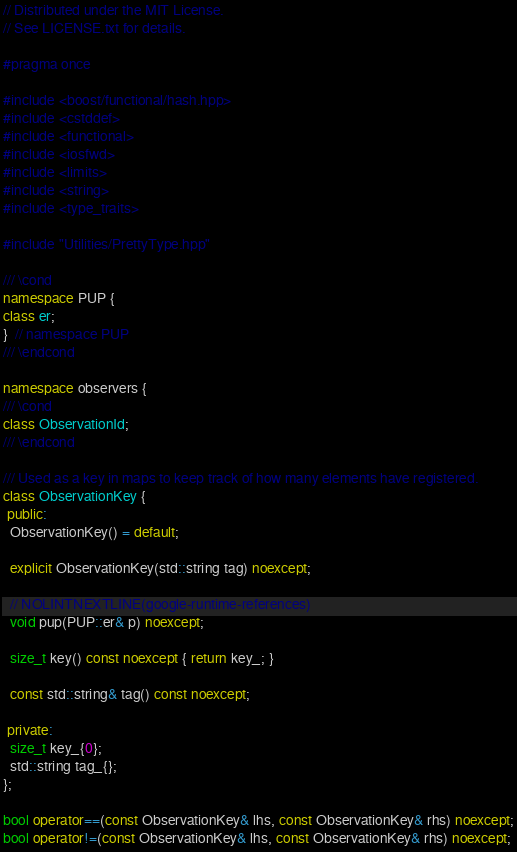Convert code to text. <code><loc_0><loc_0><loc_500><loc_500><_C++_>// Distributed under the MIT License.
// See LICENSE.txt for details.

#pragma once

#include <boost/functional/hash.hpp>
#include <cstddef>
#include <functional>
#include <iosfwd>
#include <limits>
#include <string>
#include <type_traits>

#include "Utilities/PrettyType.hpp"

/// \cond
namespace PUP {
class er;
}  // namespace PUP
/// \endcond

namespace observers {
/// \cond
class ObservationId;
/// \endcond

/// Used as a key in maps to keep track of how many elements have registered.
class ObservationKey {
 public:
  ObservationKey() = default;

  explicit ObservationKey(std::string tag) noexcept;

  // NOLINTNEXTLINE(google-runtime-references)
  void pup(PUP::er& p) noexcept;

  size_t key() const noexcept { return key_; }

  const std::string& tag() const noexcept;

 private:
  size_t key_{0};
  std::string tag_{};
};

bool operator==(const ObservationKey& lhs, const ObservationKey& rhs) noexcept;
bool operator!=(const ObservationKey& lhs, const ObservationKey& rhs) noexcept;
</code> 